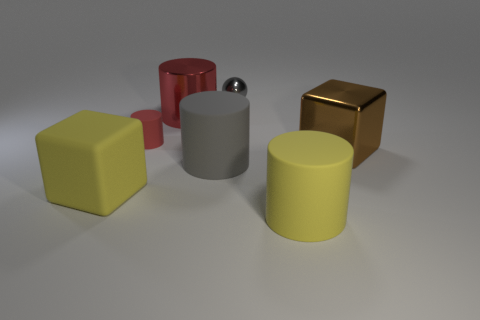How many big things are either rubber things or gray rubber things?
Your answer should be very brief. 3. Is the number of yellow matte blocks less than the number of metallic things?
Your answer should be compact. Yes. Are there any other things that have the same size as the metal cube?
Your response must be concise. Yes. Do the matte cube and the ball have the same color?
Ensure brevity in your answer.  No. Is the number of yellow matte objects greater than the number of tiny balls?
Your response must be concise. Yes. How many other objects are there of the same color as the ball?
Offer a terse response. 1. How many big brown shiny blocks are behind the big block in front of the brown metallic cube?
Make the answer very short. 1. Are there any small red objects on the right side of the gray metal sphere?
Offer a terse response. No. What is the shape of the large metallic object that is left of the gray shiny object on the left side of the brown shiny block?
Make the answer very short. Cylinder. Are there fewer large metal cubes to the right of the big brown cube than large things behind the small shiny sphere?
Give a very brief answer. No. 